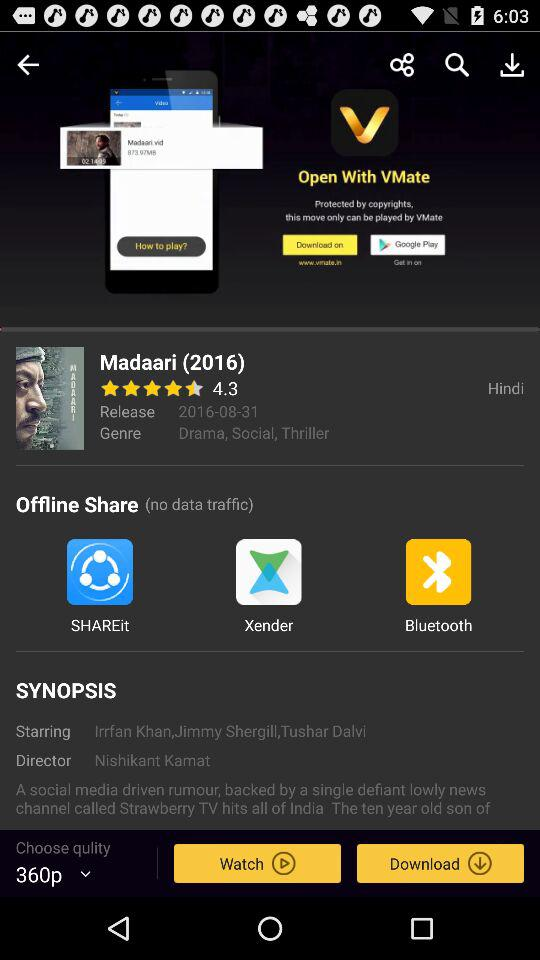What are the genres? The genres are drama, social and thriller. 